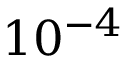Convert formula to latex. <formula><loc_0><loc_0><loc_500><loc_500>1 0 ^ { - 4 }</formula> 